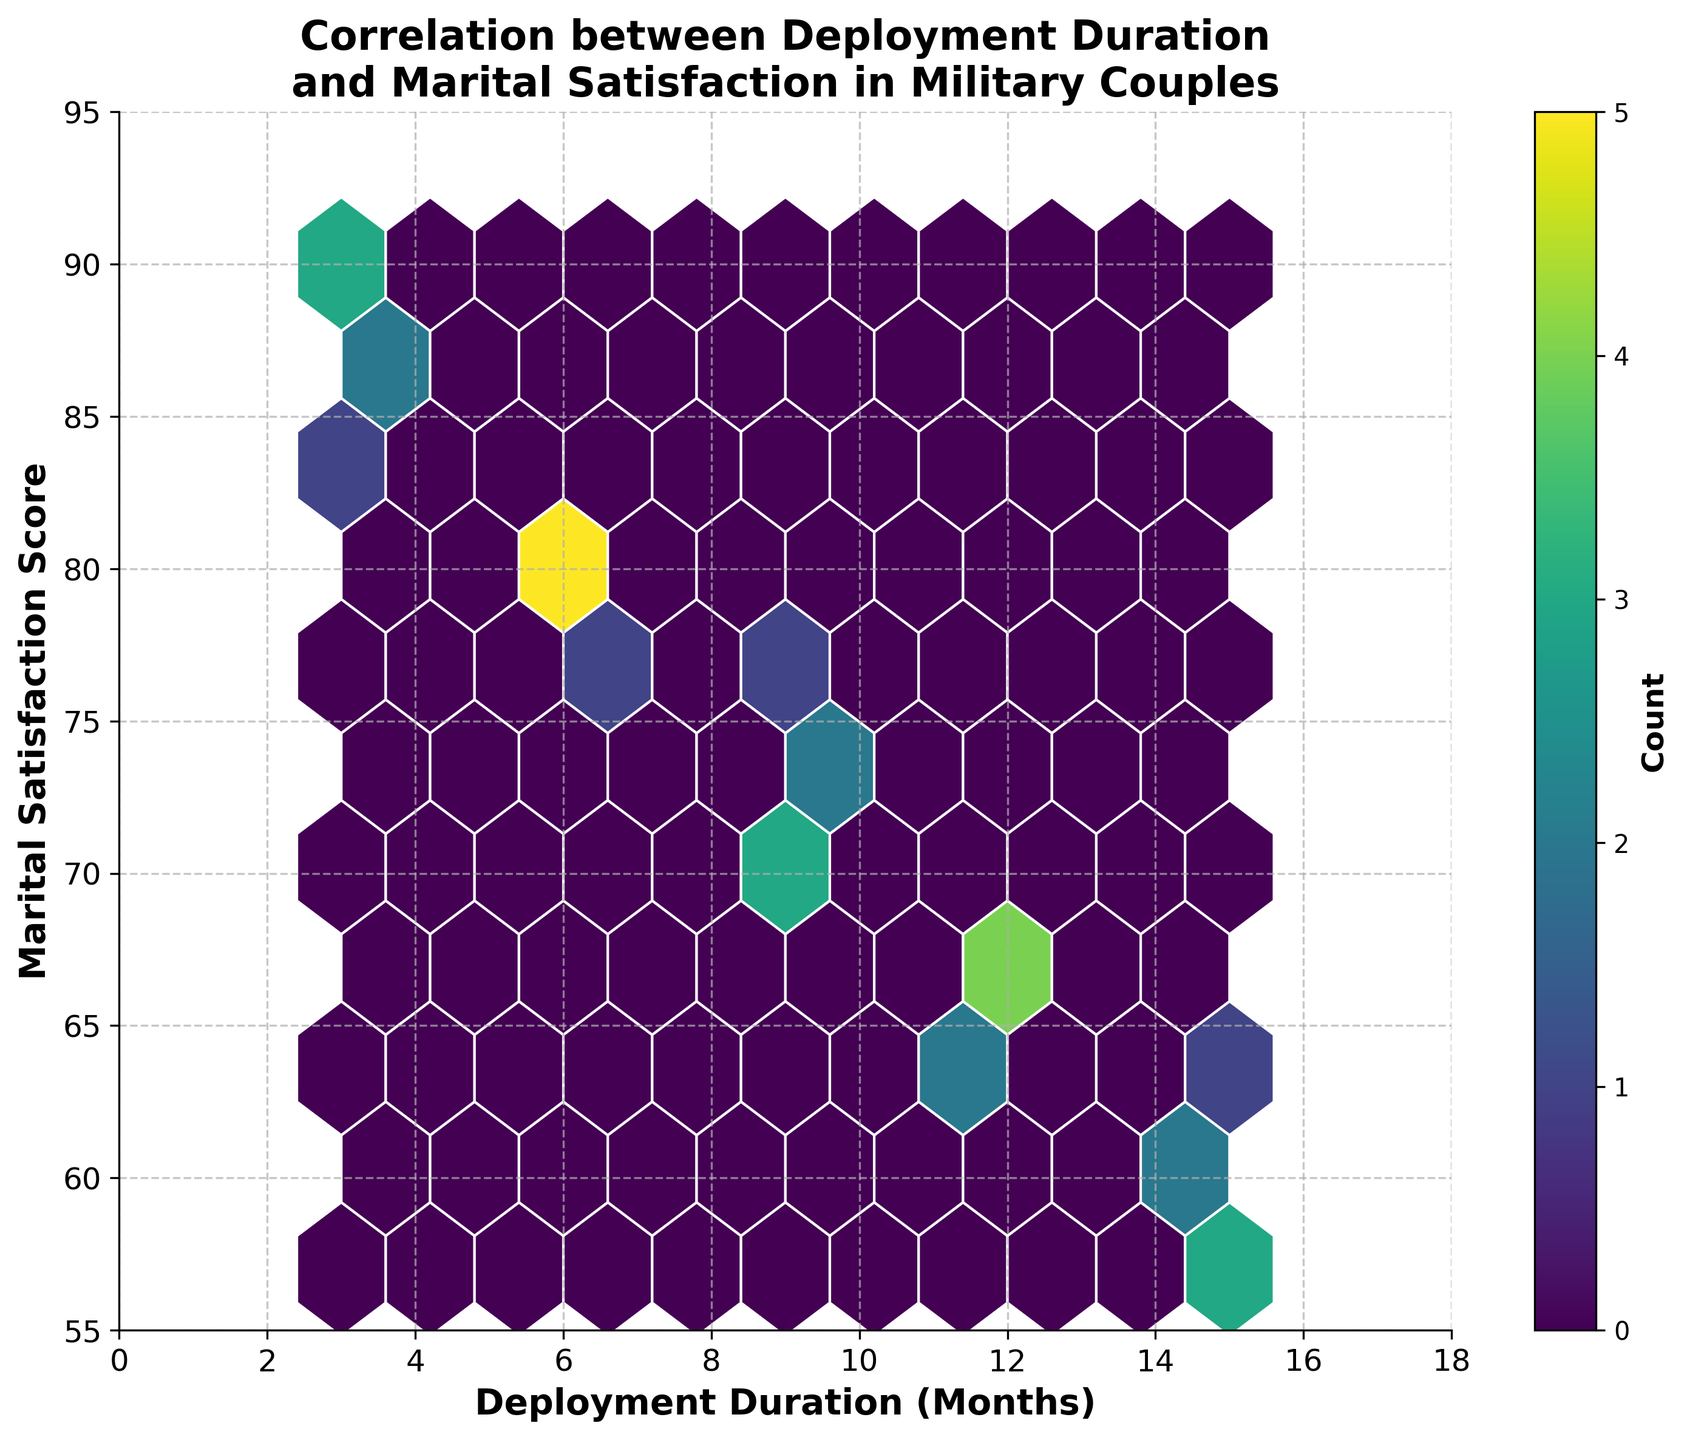What is the title of the plot? The title of the plot can be found at the top of the figure. It reads "Correlation between Deployment Duration and Marital Satisfaction in Military Couples".
Answer: Correlation between Deployment Duration and Marital Satisfaction in Military Couples What is the range of marital satisfaction scores displayed on the y-axis? The y-axis represents the marital satisfaction score. Based on the figure, the range is from 55 to 95.
Answer: 55 to 95 What is the range of deployment durations represented on the x-axis? The x-axis represents the deployment duration in months. The axis is labeled from 0 to 18 months.
Answer: 0 to 18 months How is the data visualized in the plot? The data is visualized using a hexbin plot, where each hexagon represents the count of data points that fall within that bin.
Answer: Hexbin plot What is the color of the regions with the highest density of data points? In the hexbin plot, colors represent the density of data points. The colormap used is 'viridis,' where the densest regions appear in brighter colors (light green to yellow).
Answer: Light green to yellow How does the marital satisfaction score trend with increasing deployment duration based on the plot? The plot shows a general trend where marital satisfaction scores decrease as deployment duration increases. This is seen by observing the hexagons shifting towards lower satisfaction scores with longer durations.
Answer: Decreases Is there any deployment duration with noticeably higher marital satisfaction scores? By examining the plot, the shorter deployment durations (around 3 months) have concentrations of higher marital satisfaction scores (around 85-90).
Answer: 3 months Between the deployment durations of 6 months and 9 months, which appears to have higher marital satisfaction scores? Comparing the regions, the 6-month deployment has slightly higher marital satisfaction scores (around 77-82) compared to the 9-month deployment (around 70-75).
Answer: 6-month Are there any outliers or unusual patterns in the plot? There do not appear to be any major outliers or unusual patterns in the plot. The data follows a clear trend without any unexpected deviations.
Answer: No What does the colorbar represent in the plot? The colorbar on the right side of the plot indicates the count of data points within each hexagon. Brighter colors represent higher counts.
Answer: Count 